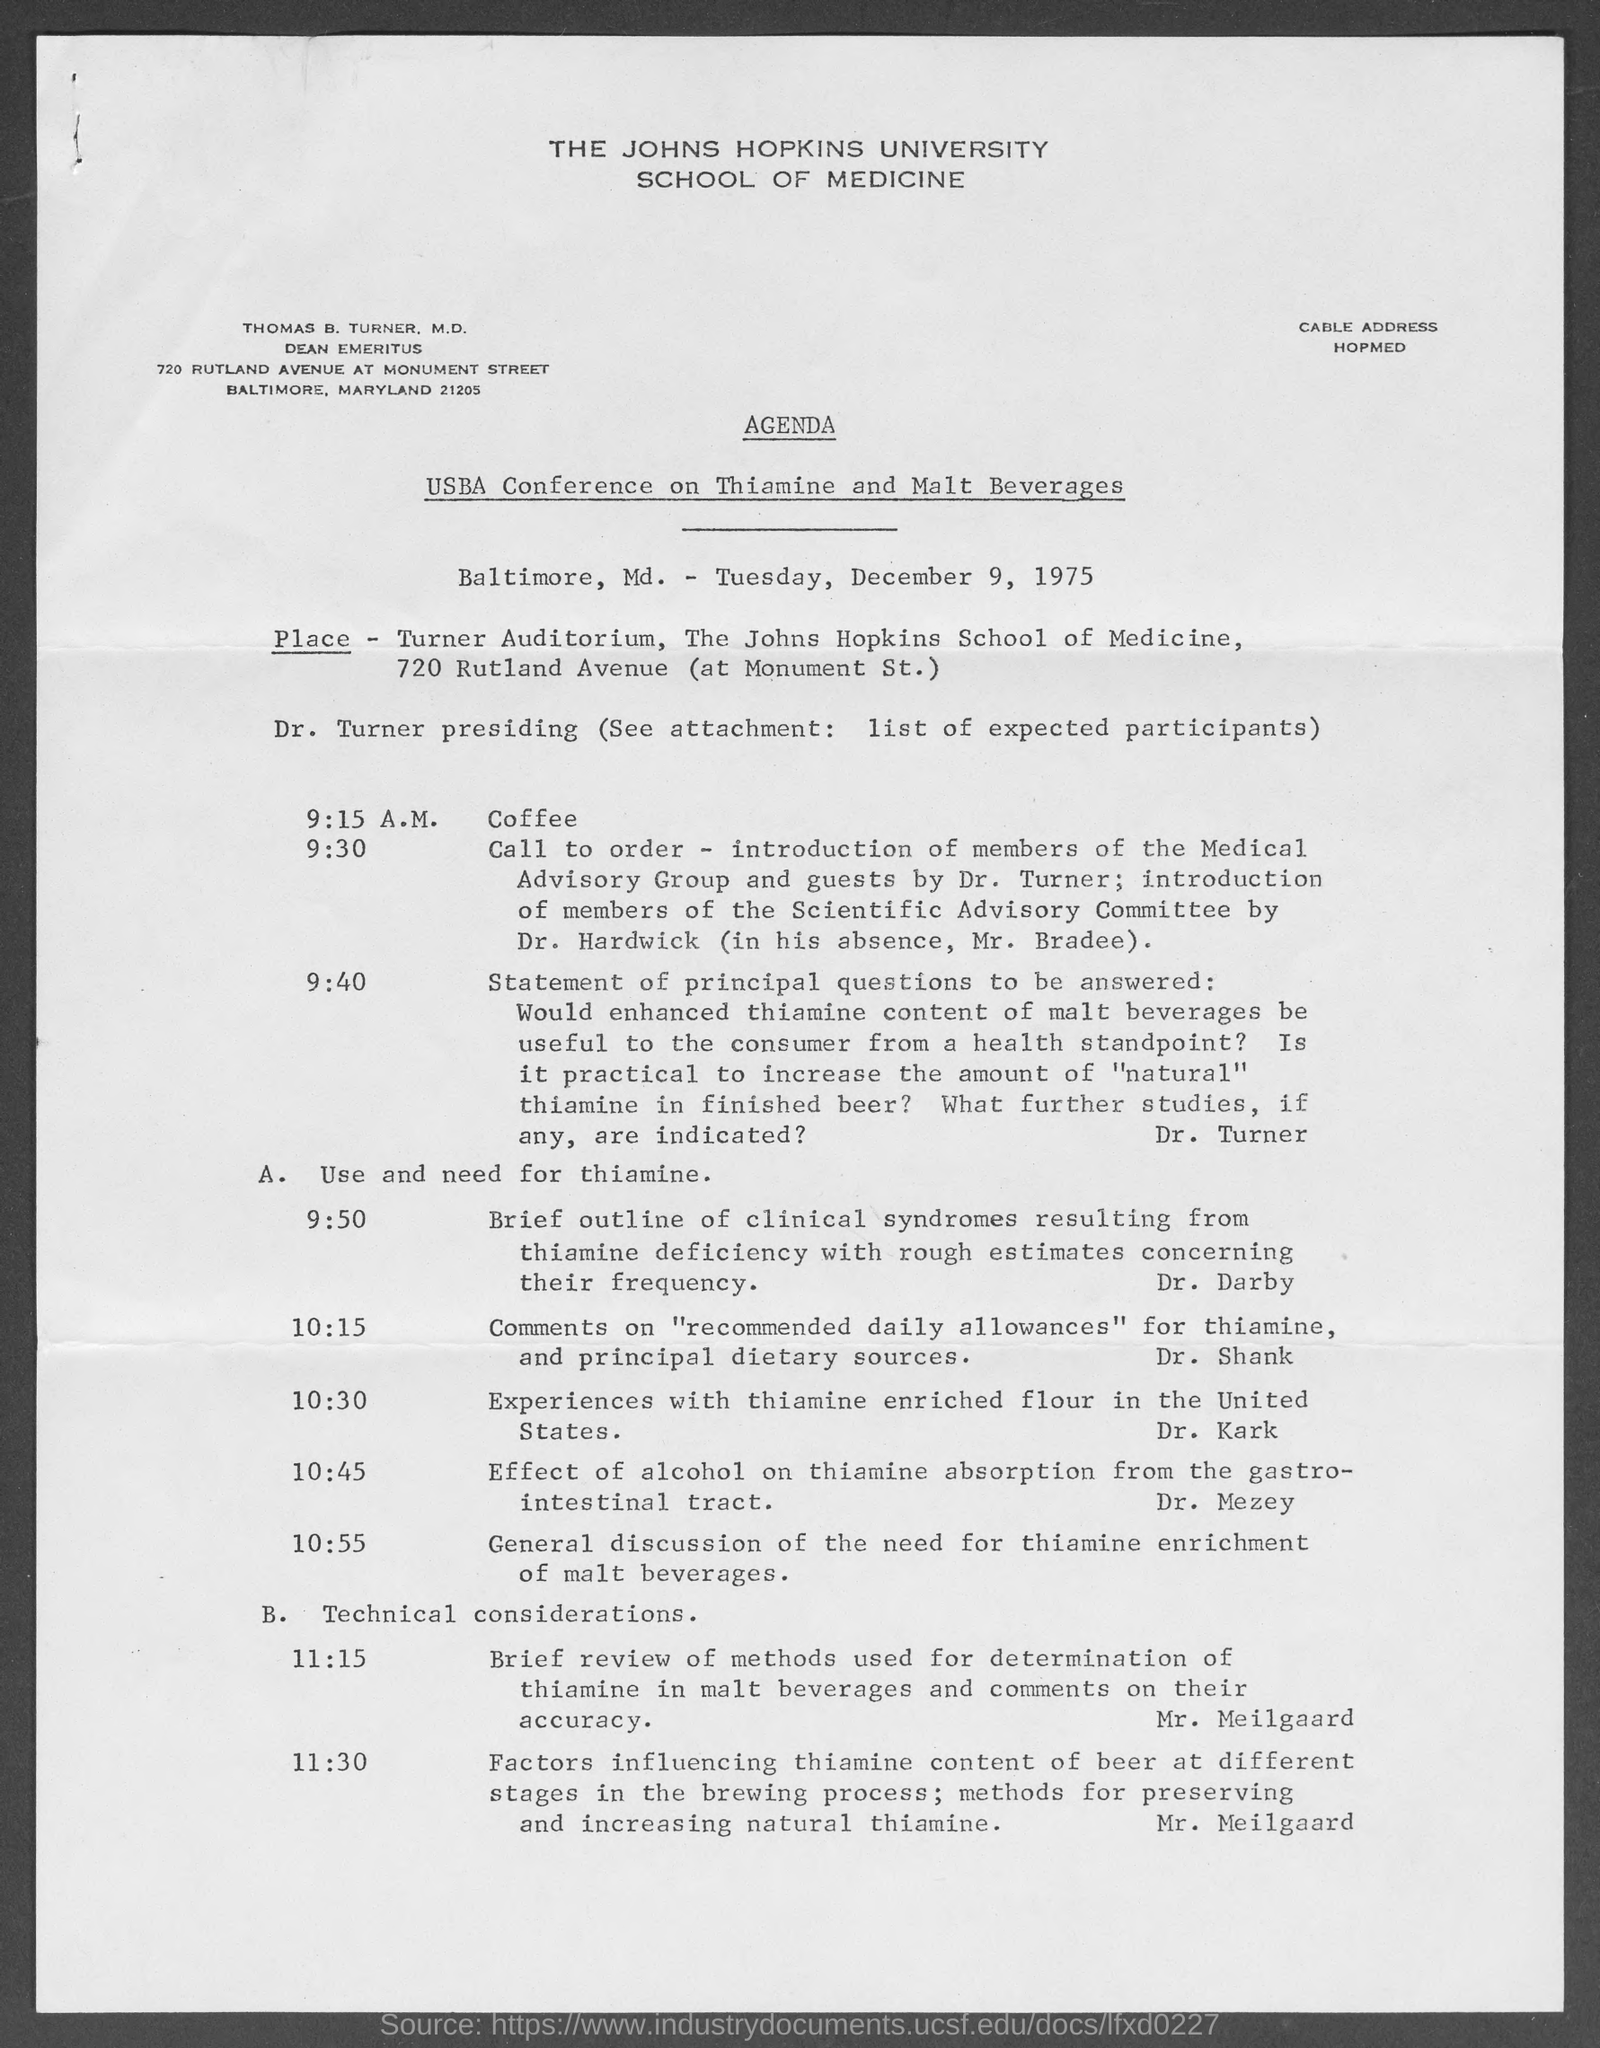What is the name of the university mentioned at top of page?
Offer a terse response. The John Hopkins University. What is usba conference on?
Offer a terse response. Thiamine and Malt Beverages. What day of the week is mentioned in the document?
Your answer should be compact. Tuesday. What time is mentioned for coffee in agenda?
Provide a succinct answer. 9:15 A.M. What time is mentioned for call to order in agenda?
Offer a terse response. 9:30. What time is mentioned for statement of principal questions to be answered in agenda?
Your answer should be compact. 9:40. 